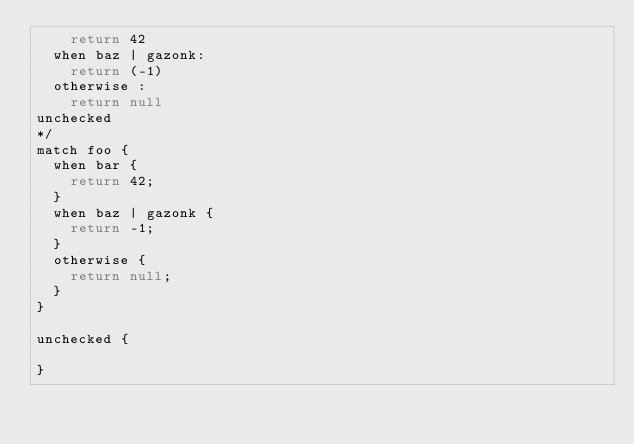Convert code to text. <code><loc_0><loc_0><loc_500><loc_500><_JavaScript_>		return 42
	when baz | gazonk:
		return (-1)
	otherwise :
		return null
unchecked
*/
match foo {
	when bar {
		return 42;
	}
	when baz | gazonk { 
		return -1;
	}
	otherwise {
		return null;
	}
}

unchecked {
	
}

</code> 